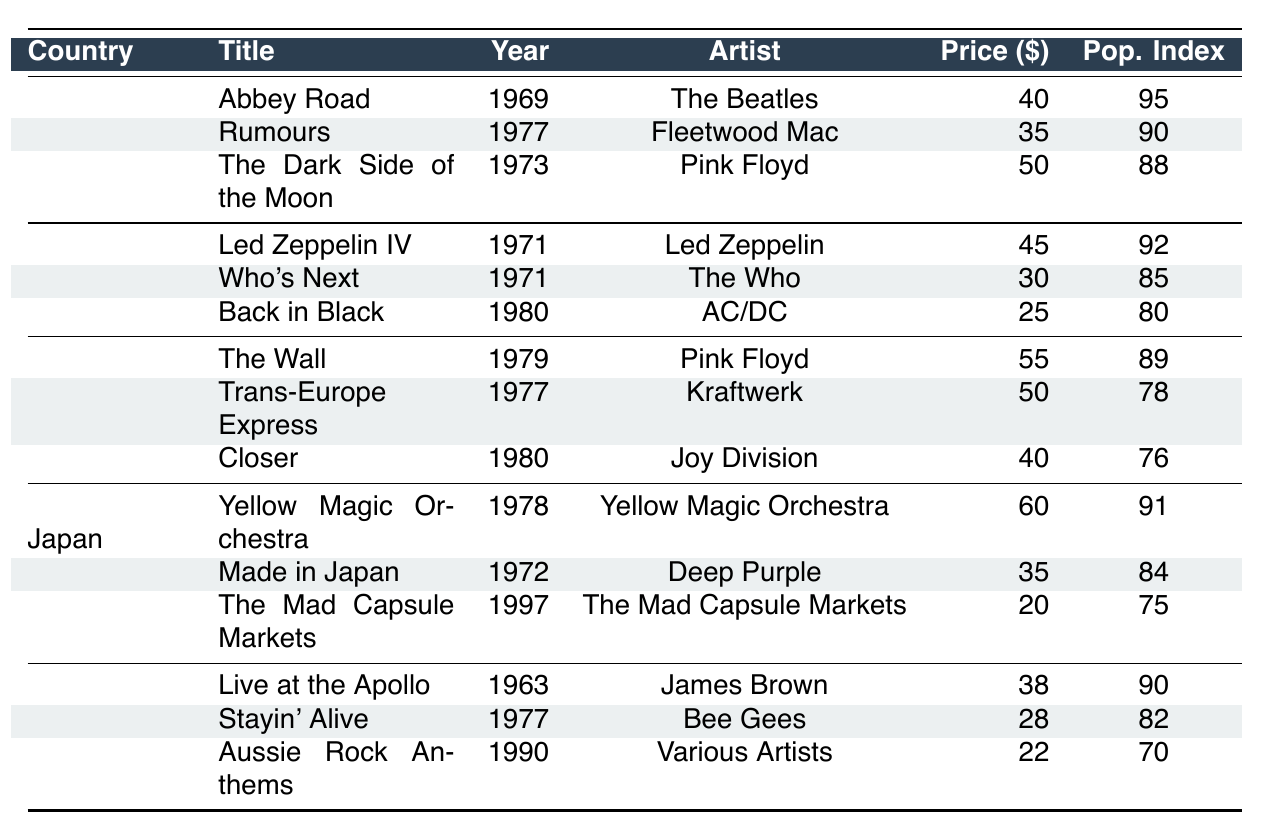What is the title of the highest-priced record from the United States? The highest-priced record from the United States is "The Dark Side of the Moon" priced at $50.
Answer: The Dark Side of the Moon Which country has the title with the lowest popularity index? The title with the lowest popularity index is "Aussie Rock Anthems" from Australia, which has a popularity index of 70.
Answer: Australia What is the average price of the top vinyl records from Japan? The prices of the top records from Japan are $60, $35, and $20. Adding these together gives $115, and dividing by 3 gives an average price of $38.33.
Answer: $38.33 Which artist has the highest popularity index among these records? The highest popularity index is 95, associated with "Abbey Road" by The Beatles.
Answer: The Beatles Is "Back in Black" from the United Kingdom? Yes, "Back in Black" is listed as one of the top vinyl records from the United Kingdom.
Answer: Yes What is the price difference between the most popular record in the United States and the most popular record in Germany? The most popular record in the United States is priced at $40, and in Germany, the most popular is priced at $55. The difference is $55 - $40 = $15.
Answer: $15 Which record from Germany has a better condition than "Closer"? "The Wall" is in "Mint" condition, which is better than "Very Good" condition of "Closer."
Answer: The Wall How many records from Australia have a popularity index above 80? There are two records from Australia with a popularity index above 80: "Live at the Apollo" with 90 and "Stayin' Alive" with 82.
Answer: 2 What is the year of release for "Made in Japan"? "Made in Japan" was released in 1972.
Answer: 1972 What is the average popularity index of the top titles from the United Kingdom? The popularity indices for the UK records are 92, 85, and 80. Summing gives 257, and dividing by 3 results in an average of 85.67.
Answer: 85.67 